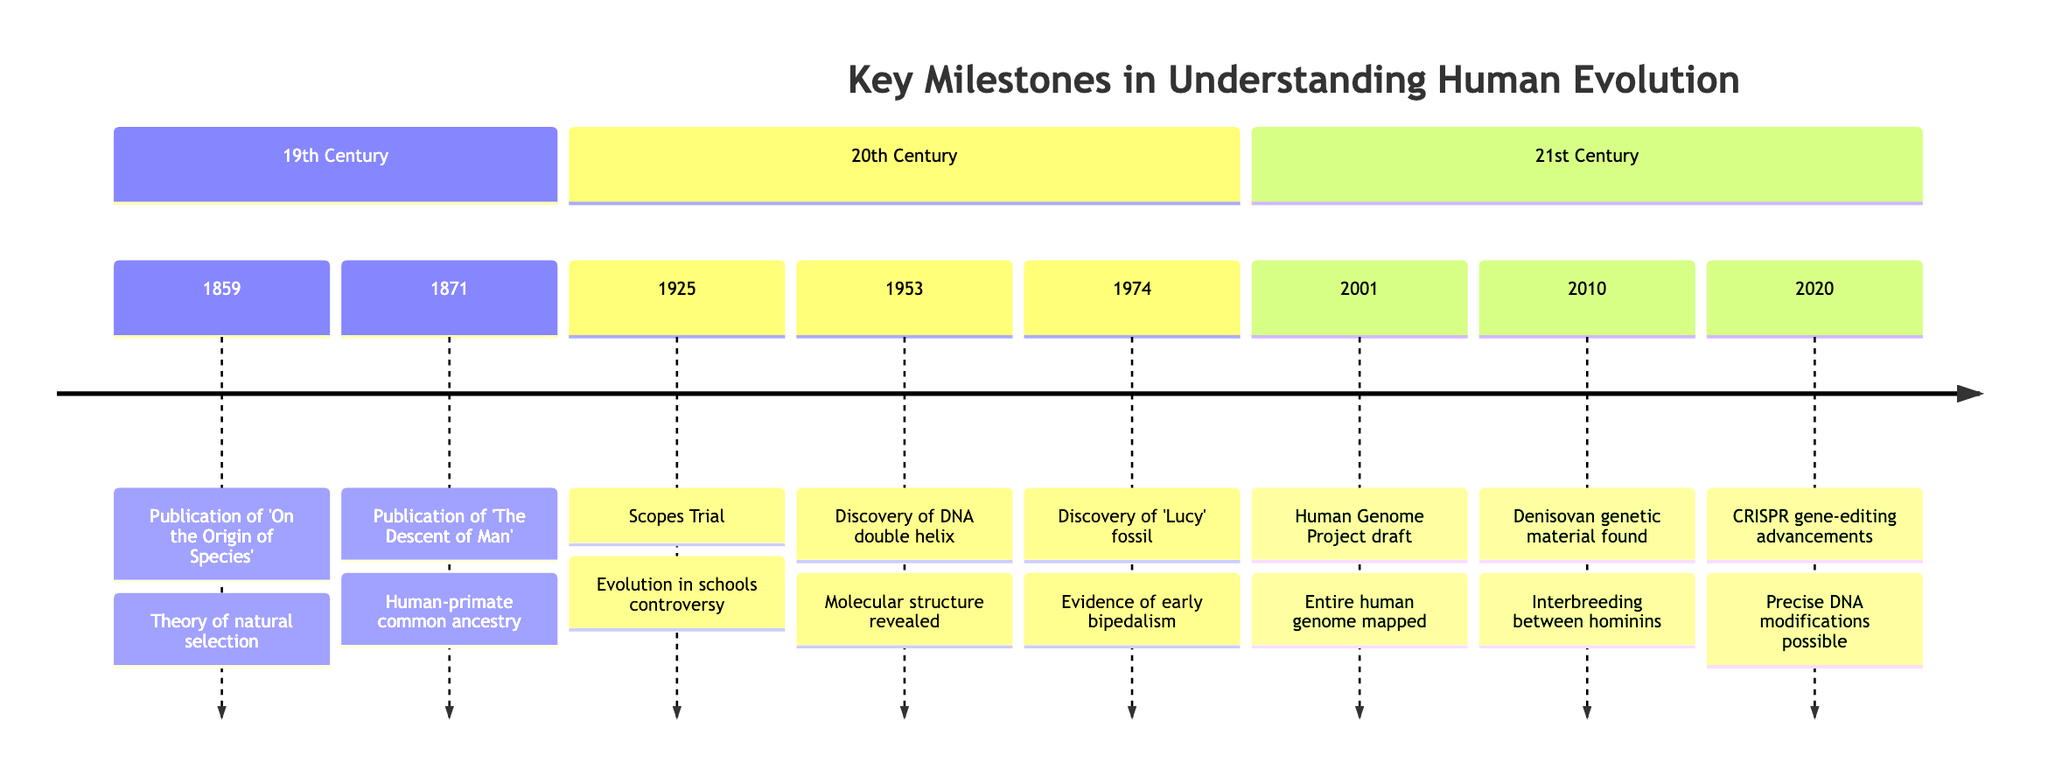What is the earliest event listed in the timeline? The timeline starts in 1859 with the publication of 'On the Origin of Species' by Charles Darwin, making it the earliest event.
Answer: 1859 How many milestones are there in the 20th Century section? The timeline shows three milestones in the 20th Century: the Scopes Trial (1925), the discovery of the DNA double helix (1953), and the discovery of 'Lucy' (1974).
Answer: 3 What significant discovery was made in 1953? In 1953, the discovery of the DNA double helix by James Watson and Francis Crick was made, which is a key milestone in genetics.
Answer: DNA double helix Which event questions human uniqueness? The publication of 'The Descent of Man' in 1871 questions human uniqueness by suggesting common ancestry with other primates.
Answer: The Descent of Man What development occurred in 2020 regarding genetics? The timeline states that in 2020, advancements in CRISPR gene-editing technology took place, providing precise DNA modifications.
Answer: CRISPR gene-editing advancements Which event mentions societal resistance to evolution? The Scopes Trial in 1925 highlights the controversy and societal resistance regarding the teaching of evolution in schools.
Answer: Scopes Trial Which milestone was marked by the mapping of the human genome? The completion of the first draft of the Human Genome Project in 2001 marked the milestone of mapping the entire human genome.
Answer: Human Genome Project draft What does the discovery of Denisovan genetic material challenge? The discovery in 2010 challenges the simplistic view of human evolution as linear, suggesting a more complex web of relationships.
Answer: Linear progression What is the philosophical interpretation of the 1859 event? The philosophical interpretation of the publication of 'On the Origin of Species' in 1859 is that it challenges fixed, immutable species, promoting a fluid concept of evolution.
Answer: Fluid concept of evolution 